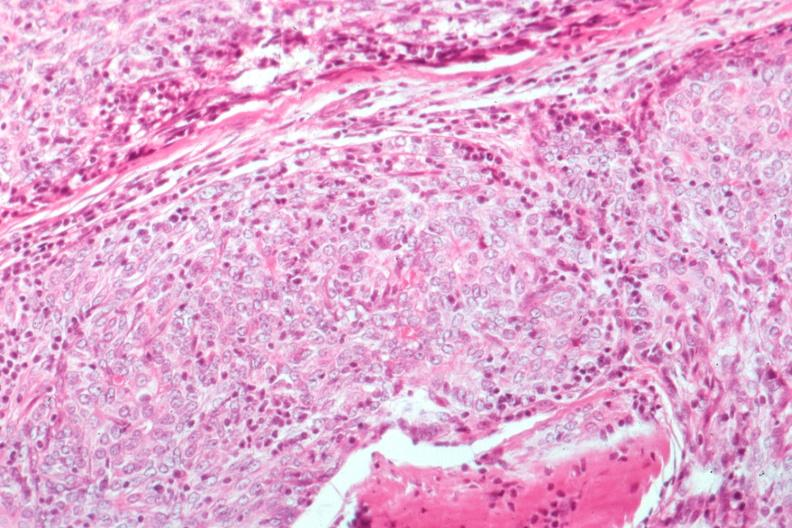s dysplastic present?
Answer the question using a single word or phrase. No 